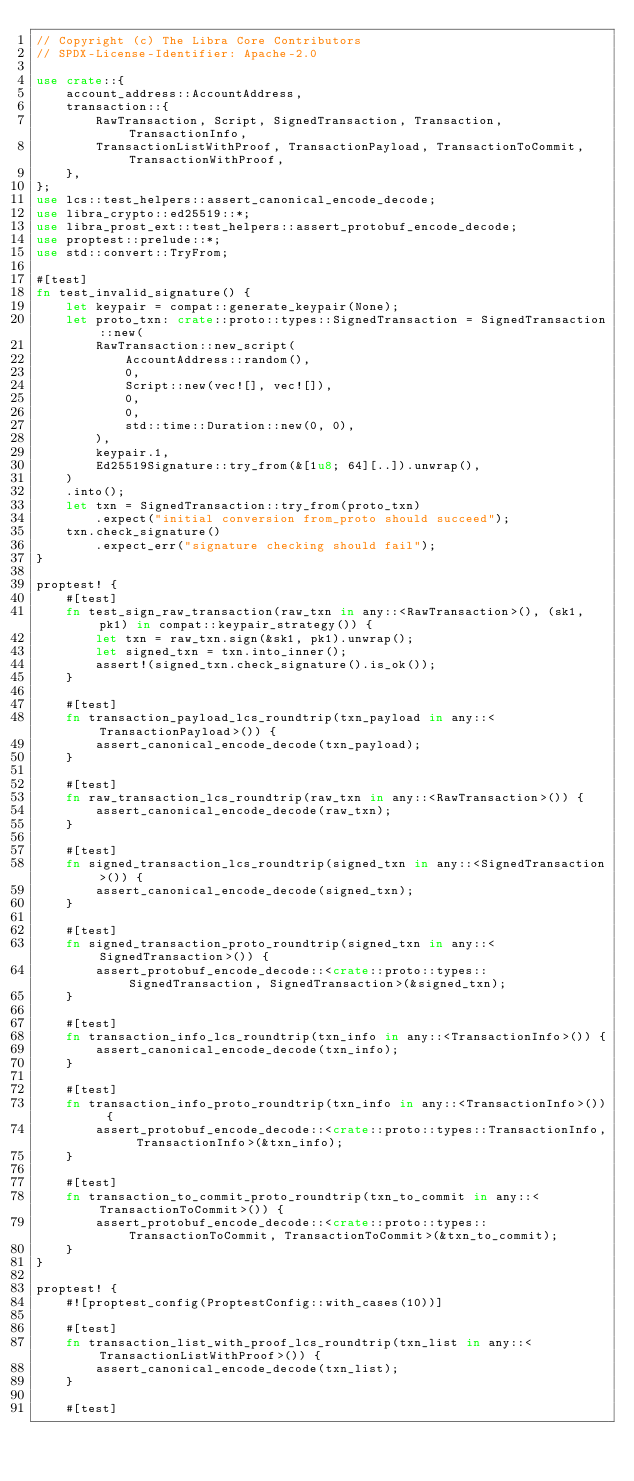Convert code to text. <code><loc_0><loc_0><loc_500><loc_500><_Rust_>// Copyright (c) The Libra Core Contributors
// SPDX-License-Identifier: Apache-2.0

use crate::{
    account_address::AccountAddress,
    transaction::{
        RawTransaction, Script, SignedTransaction, Transaction, TransactionInfo,
        TransactionListWithProof, TransactionPayload, TransactionToCommit, TransactionWithProof,
    },
};
use lcs::test_helpers::assert_canonical_encode_decode;
use libra_crypto::ed25519::*;
use libra_prost_ext::test_helpers::assert_protobuf_encode_decode;
use proptest::prelude::*;
use std::convert::TryFrom;

#[test]
fn test_invalid_signature() {
    let keypair = compat::generate_keypair(None);
    let proto_txn: crate::proto::types::SignedTransaction = SignedTransaction::new(
        RawTransaction::new_script(
            AccountAddress::random(),
            0,
            Script::new(vec![], vec![]),
            0,
            0,
            std::time::Duration::new(0, 0),
        ),
        keypair.1,
        Ed25519Signature::try_from(&[1u8; 64][..]).unwrap(),
    )
    .into();
    let txn = SignedTransaction::try_from(proto_txn)
        .expect("initial conversion from_proto should succeed");
    txn.check_signature()
        .expect_err("signature checking should fail");
}

proptest! {
    #[test]
    fn test_sign_raw_transaction(raw_txn in any::<RawTransaction>(), (sk1, pk1) in compat::keypair_strategy()) {
        let txn = raw_txn.sign(&sk1, pk1).unwrap();
        let signed_txn = txn.into_inner();
        assert!(signed_txn.check_signature().is_ok());
    }

    #[test]
    fn transaction_payload_lcs_roundtrip(txn_payload in any::<TransactionPayload>()) {
        assert_canonical_encode_decode(txn_payload);
    }

    #[test]
    fn raw_transaction_lcs_roundtrip(raw_txn in any::<RawTransaction>()) {
        assert_canonical_encode_decode(raw_txn);
    }

    #[test]
    fn signed_transaction_lcs_roundtrip(signed_txn in any::<SignedTransaction>()) {
        assert_canonical_encode_decode(signed_txn);
    }

    #[test]
    fn signed_transaction_proto_roundtrip(signed_txn in any::<SignedTransaction>()) {
        assert_protobuf_encode_decode::<crate::proto::types::SignedTransaction, SignedTransaction>(&signed_txn);
    }

    #[test]
    fn transaction_info_lcs_roundtrip(txn_info in any::<TransactionInfo>()) {
        assert_canonical_encode_decode(txn_info);
    }

    #[test]
    fn transaction_info_proto_roundtrip(txn_info in any::<TransactionInfo>()) {
        assert_protobuf_encode_decode::<crate::proto::types::TransactionInfo, TransactionInfo>(&txn_info);
    }

    #[test]
    fn transaction_to_commit_proto_roundtrip(txn_to_commit in any::<TransactionToCommit>()) {
        assert_protobuf_encode_decode::<crate::proto::types::TransactionToCommit, TransactionToCommit>(&txn_to_commit);
    }
}

proptest! {
    #![proptest_config(ProptestConfig::with_cases(10))]

    #[test]
    fn transaction_list_with_proof_lcs_roundtrip(txn_list in any::<TransactionListWithProof>()) {
        assert_canonical_encode_decode(txn_list);
    }

    #[test]</code> 